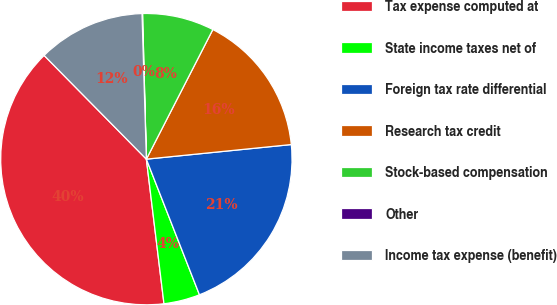Convert chart to OTSL. <chart><loc_0><loc_0><loc_500><loc_500><pie_chart><fcel>Tax expense computed at<fcel>State income taxes net of<fcel>Foreign tax rate differential<fcel>Research tax credit<fcel>Stock-based compensation<fcel>Other<fcel>Income tax expense (benefit)<nl><fcel>39.54%<fcel>4.01%<fcel>20.66%<fcel>15.86%<fcel>7.96%<fcel>0.06%<fcel>11.91%<nl></chart> 